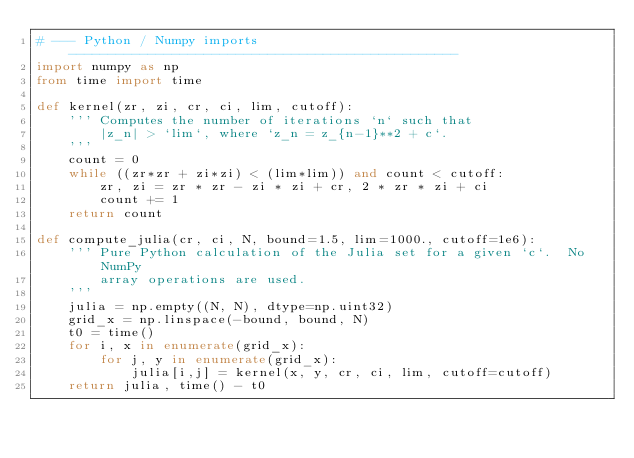Convert code to text. <code><loc_0><loc_0><loc_500><loc_500><_Python_># --- Python / Numpy imports -------------------------------------------------
import numpy as np
from time import time

def kernel(zr, zi, cr, ci, lim, cutoff):
    ''' Computes the number of iterations `n` such that 
        |z_n| > `lim`, where `z_n = z_{n-1}**2 + c`.
    '''
    count = 0
    while ((zr*zr + zi*zi) < (lim*lim)) and count < cutoff:
        zr, zi = zr * zr - zi * zi + cr, 2 * zr * zi + ci
        count += 1
    return count

def compute_julia(cr, ci, N, bound=1.5, lim=1000., cutoff=1e6):
    ''' Pure Python calculation of the Julia set for a given `c`.  No NumPy
        array operations are used.
    '''
    julia = np.empty((N, N), dtype=np.uint32)
    grid_x = np.linspace(-bound, bound, N)
    t0 = time()
    for i, x in enumerate(grid_x):
        for j, y in enumerate(grid_x):
            julia[i,j] = kernel(x, y, cr, ci, lim, cutoff=cutoff)
    return julia, time() - t0
</code> 